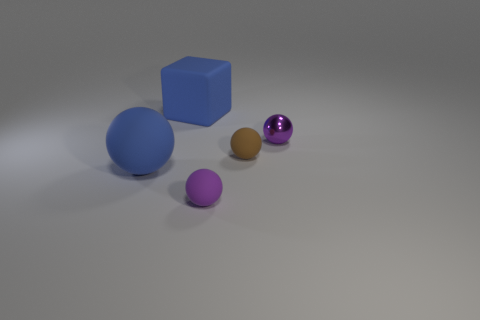There is a large object that is the same color as the large rubber cube; what is it made of?
Your response must be concise. Rubber. There is a matte thing that is in front of the big sphere; is there a tiny ball that is left of it?
Make the answer very short. No. Do the small purple shiny thing and the small rubber thing behind the tiny purple matte ball have the same shape?
Ensure brevity in your answer.  Yes. What is the color of the large matte object that is behind the tiny brown object?
Make the answer very short. Blue. There is a matte cube that is on the right side of the large object that is in front of the big rubber block; what is its size?
Give a very brief answer. Large. Is the shape of the tiny rubber thing left of the tiny brown ball the same as  the tiny brown thing?
Offer a very short reply. Yes. There is a big blue thing that is the same shape as the small brown object; what is its material?
Make the answer very short. Rubber. What number of objects are either tiny purple spheres that are on the right side of the purple rubber sphere or small spheres that are left of the metallic sphere?
Your answer should be very brief. 3. There is a small metal object; is it the same color as the small matte thing that is right of the purple matte object?
Make the answer very short. No. There is a big blue object that is the same material as the big cube; what is its shape?
Keep it short and to the point. Sphere. 